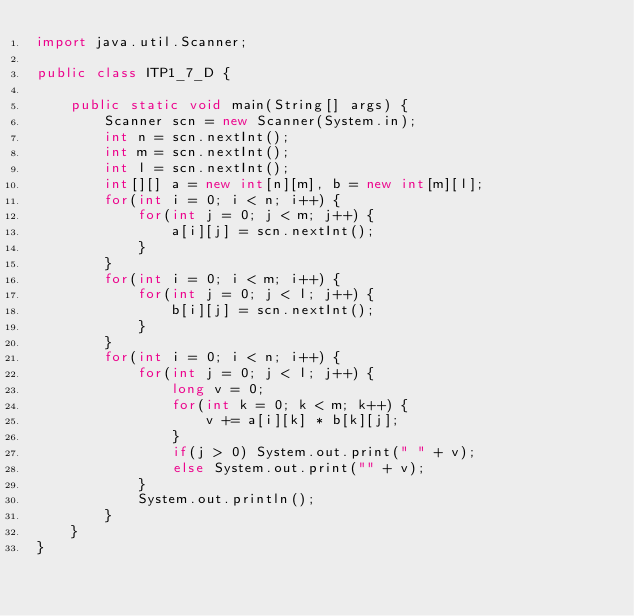Convert code to text. <code><loc_0><loc_0><loc_500><loc_500><_Java_>import java.util.Scanner;

public class ITP1_7_D {

    public static void main(String[] args) {
        Scanner scn = new Scanner(System.in);
        int n = scn.nextInt();
        int m = scn.nextInt();
        int l = scn.nextInt();
        int[][] a = new int[n][m], b = new int[m][l];
        for(int i = 0; i < n; i++) {
            for(int j = 0; j < m; j++) {
                a[i][j] = scn.nextInt();
            }
        }
        for(int i = 0; i < m; i++) {
            for(int j = 0; j < l; j++) {
                b[i][j] = scn.nextInt();
            }
        }
        for(int i = 0; i < n; i++) {
            for(int j = 0; j < l; j++) {
                long v = 0;
                for(int k = 0; k < m; k++) {
                    v += a[i][k] * b[k][j];
                }
                if(j > 0) System.out.print(" " + v);
                else System.out.print("" + v);
            }
            System.out.println();
        }
    }
}</code> 